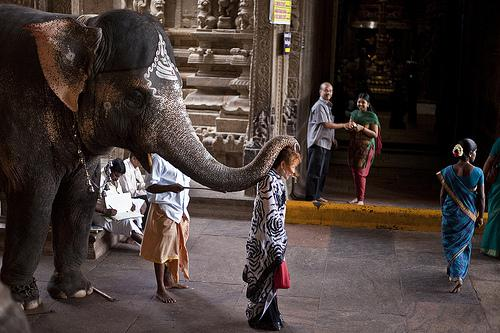Question: where was the photo taken?
Choices:
A. At a school.
B. At a park.
C. At a performance.
D. At a library.
Answer with the letter. Answer: C Question: what is gray?
Choices:
A. Dog.
B. Mouse.
C. Elephant.
D. Seal.
Answer with the letter. Answer: C Question: who has a trunk?
Choices:
A. An elephant.
B. Tree.
C. Person.
D. A house.
Answer with the letter. Answer: A Question: how many people are wearing blue?
Choices:
A. Two.
B. Only one.
C. Four.
D. Six.
Answer with the letter. Answer: B Question: when was the picture taken?
Choices:
A. Afternoon.
B. Night.
C. Morning.
D. Dawn.
Answer with the letter. Answer: B Question: how many elephants are there?
Choices:
A. One.
B. Two.
C. Three.
D. Four.
Answer with the letter. Answer: A 